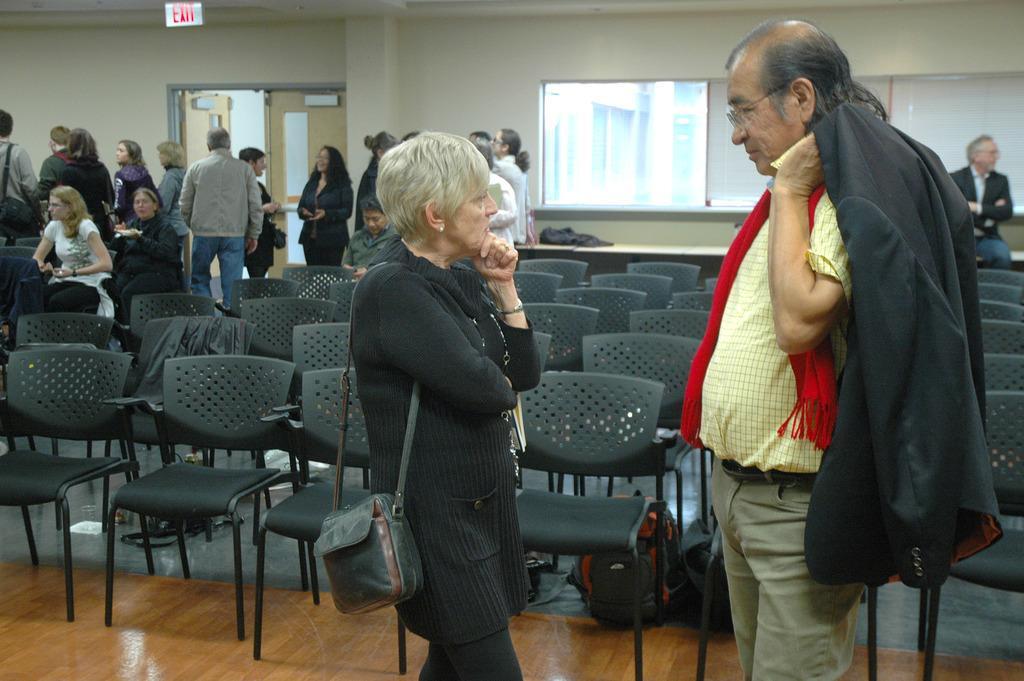Please provide a concise description of this image. This picture shows few people standing and few are seated on the chairs and we see bags and we see a woman and a man speaking to each other and we see man holding a coat in his hand and women wore handbag and we see white board and a sign board to the roof and we see empty chairs. 